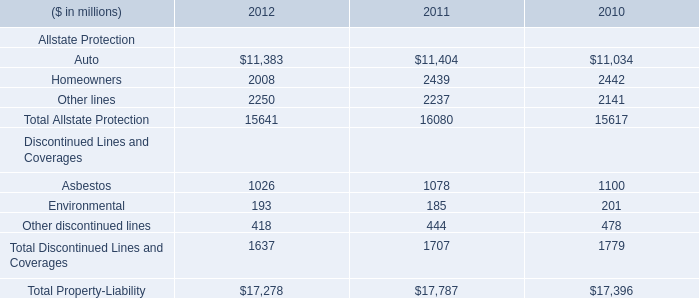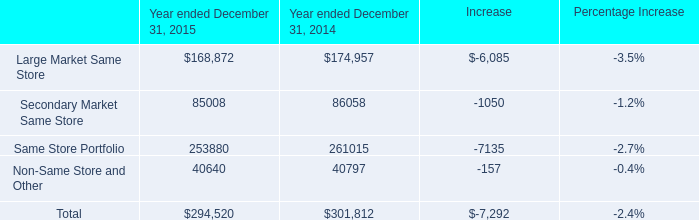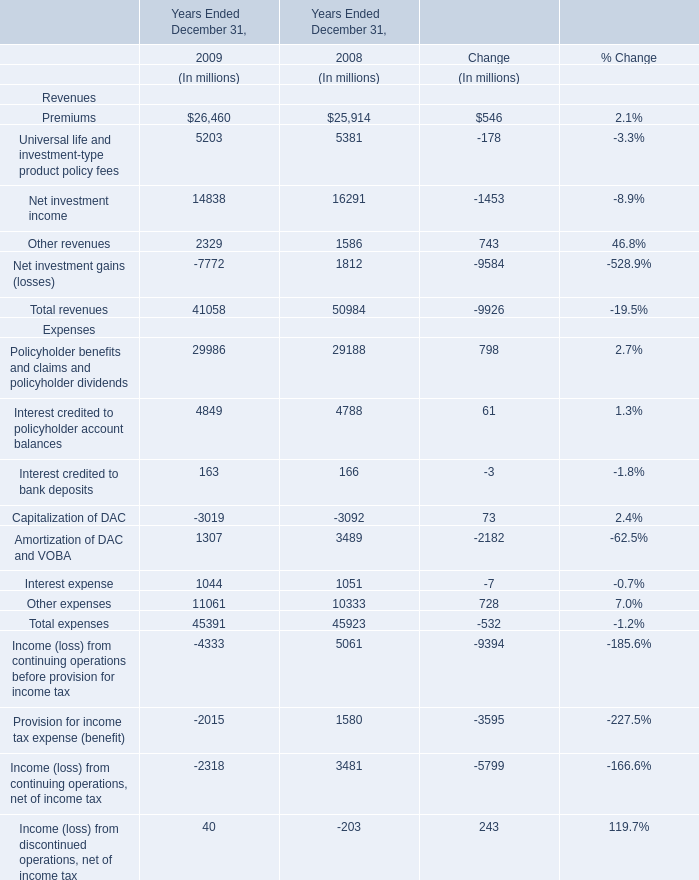If Other revenues develops with the same growth rate in 2009 Ended December 31, what will it reach in 2010 Ended December 31? (in million) 
Computations: (2329 * (1 + ((2329 - 1586) / 1586)))
Answer: 3420.07629. 